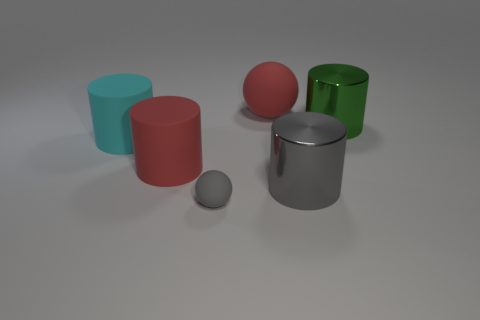Are there any other things that have the same shape as the small rubber object?
Make the answer very short. Yes. Are there the same number of big cyan things on the right side of the big red cylinder and small spheres?
Your response must be concise. No. How many purple cubes have the same material as the large red sphere?
Offer a very short reply. 0. What color is the other cylinder that is made of the same material as the large red cylinder?
Your response must be concise. Cyan. Does the big green metallic object have the same shape as the small gray rubber thing?
Give a very brief answer. No. Is there a large metal object in front of the gray thing on the right side of the big red matte thing behind the big green metal object?
Make the answer very short. No. What number of large rubber cylinders are the same color as the big rubber ball?
Ensure brevity in your answer.  1. What shape is the green metallic thing that is the same size as the red sphere?
Ensure brevity in your answer.  Cylinder. Are there any gray metal things left of the red cylinder?
Give a very brief answer. No. Does the green thing have the same size as the gray shiny cylinder?
Ensure brevity in your answer.  Yes. 